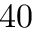Convert formula to latex. <formula><loc_0><loc_0><loc_500><loc_500>4 0</formula> 